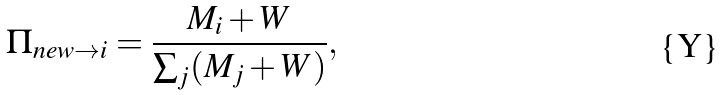<formula> <loc_0><loc_0><loc_500><loc_500>\Pi _ { n e w \rightarrow i } = \frac { M _ { i } + W } { \sum _ { j } ( M _ { j } + W ) } ,</formula> 